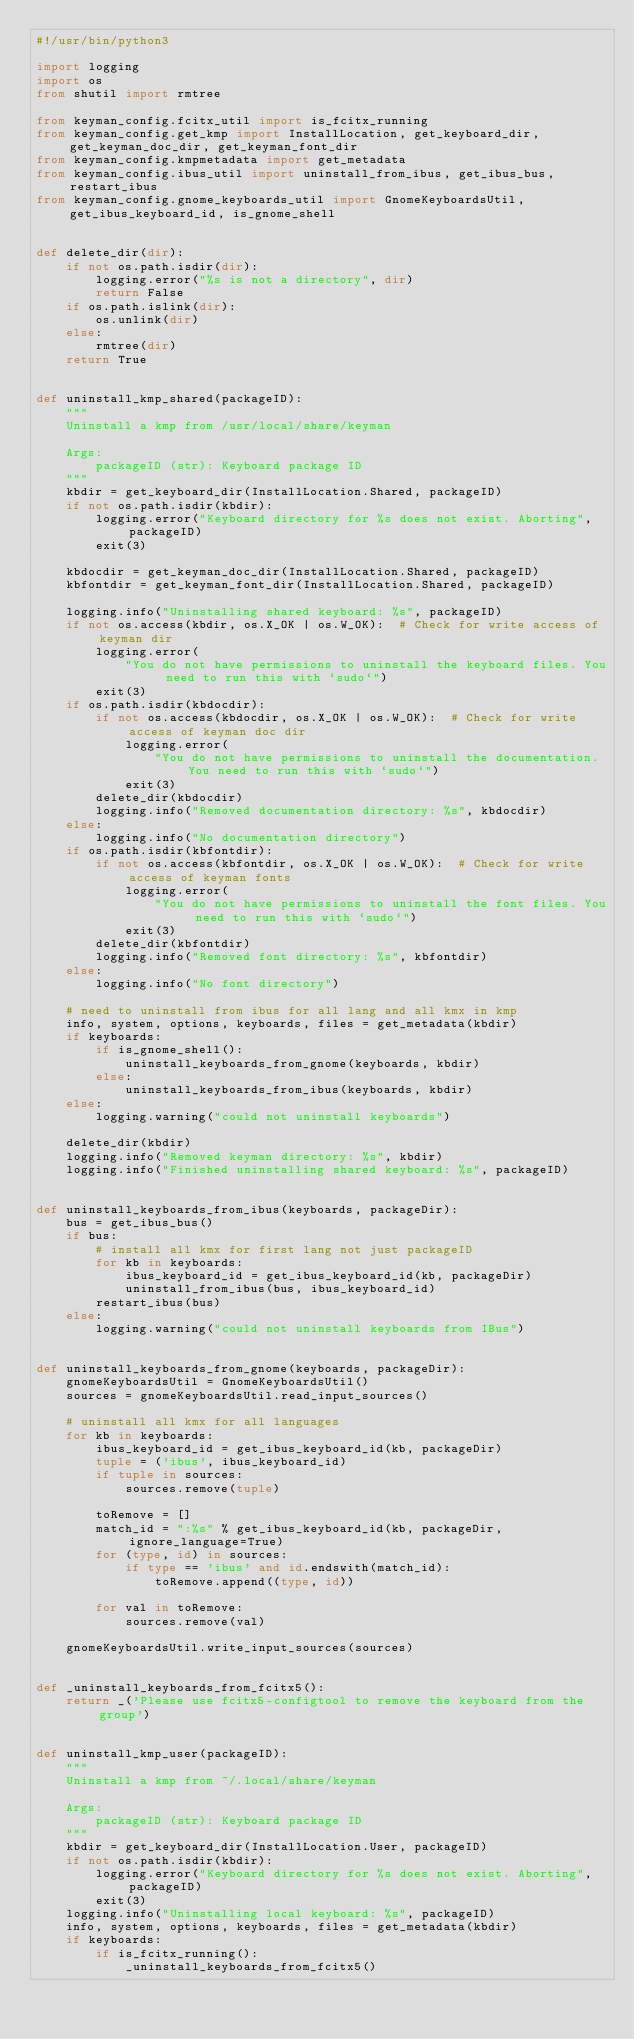<code> <loc_0><loc_0><loc_500><loc_500><_Python_>#!/usr/bin/python3

import logging
import os
from shutil import rmtree

from keyman_config.fcitx_util import is_fcitx_running
from keyman_config.get_kmp import InstallLocation, get_keyboard_dir, get_keyman_doc_dir, get_keyman_font_dir
from keyman_config.kmpmetadata import get_metadata
from keyman_config.ibus_util import uninstall_from_ibus, get_ibus_bus, restart_ibus
from keyman_config.gnome_keyboards_util import GnomeKeyboardsUtil, get_ibus_keyboard_id, is_gnome_shell


def delete_dir(dir):
    if not os.path.isdir(dir):
        logging.error("%s is not a directory", dir)
        return False
    if os.path.islink(dir):
        os.unlink(dir)
    else:
        rmtree(dir)
    return True


def uninstall_kmp_shared(packageID):
    """
    Uninstall a kmp from /usr/local/share/keyman

    Args:
        packageID (str): Keyboard package ID
    """
    kbdir = get_keyboard_dir(InstallLocation.Shared, packageID)
    if not os.path.isdir(kbdir):
        logging.error("Keyboard directory for %s does not exist. Aborting", packageID)
        exit(3)

    kbdocdir = get_keyman_doc_dir(InstallLocation.Shared, packageID)
    kbfontdir = get_keyman_font_dir(InstallLocation.Shared, packageID)

    logging.info("Uninstalling shared keyboard: %s", packageID)
    if not os.access(kbdir, os.X_OK | os.W_OK):  # Check for write access of keyman dir
        logging.error(
            "You do not have permissions to uninstall the keyboard files. You need to run this with `sudo`")
        exit(3)
    if os.path.isdir(kbdocdir):
        if not os.access(kbdocdir, os.X_OK | os.W_OK):  # Check for write access of keyman doc dir
            logging.error(
                "You do not have permissions to uninstall the documentation. You need to run this with `sudo`")
            exit(3)
        delete_dir(kbdocdir)
        logging.info("Removed documentation directory: %s", kbdocdir)
    else:
        logging.info("No documentation directory")
    if os.path.isdir(kbfontdir):
        if not os.access(kbfontdir, os.X_OK | os.W_OK):  # Check for write access of keyman fonts
            logging.error(
                "You do not have permissions to uninstall the font files. You need to run this with `sudo`")
            exit(3)
        delete_dir(kbfontdir)
        logging.info("Removed font directory: %s", kbfontdir)
    else:
        logging.info("No font directory")

    # need to uninstall from ibus for all lang and all kmx in kmp
    info, system, options, keyboards, files = get_metadata(kbdir)
    if keyboards:
        if is_gnome_shell():
            uninstall_keyboards_from_gnome(keyboards, kbdir)
        else:
            uninstall_keyboards_from_ibus(keyboards, kbdir)
    else:
        logging.warning("could not uninstall keyboards")

    delete_dir(kbdir)
    logging.info("Removed keyman directory: %s", kbdir)
    logging.info("Finished uninstalling shared keyboard: %s", packageID)


def uninstall_keyboards_from_ibus(keyboards, packageDir):
    bus = get_ibus_bus()
    if bus:
        # install all kmx for first lang not just packageID
        for kb in keyboards:
            ibus_keyboard_id = get_ibus_keyboard_id(kb, packageDir)
            uninstall_from_ibus(bus, ibus_keyboard_id)
        restart_ibus(bus)
    else:
        logging.warning("could not uninstall keyboards from IBus")


def uninstall_keyboards_from_gnome(keyboards, packageDir):
    gnomeKeyboardsUtil = GnomeKeyboardsUtil()
    sources = gnomeKeyboardsUtil.read_input_sources()

    # uninstall all kmx for all languages
    for kb in keyboards:
        ibus_keyboard_id = get_ibus_keyboard_id(kb, packageDir)
        tuple = ('ibus', ibus_keyboard_id)
        if tuple in sources:
            sources.remove(tuple)

        toRemove = []
        match_id = ":%s" % get_ibus_keyboard_id(kb, packageDir, ignore_language=True)
        for (type, id) in sources:
            if type == 'ibus' and id.endswith(match_id):
                toRemove.append((type, id))

        for val in toRemove:
            sources.remove(val)

    gnomeKeyboardsUtil.write_input_sources(sources)


def _uninstall_keyboards_from_fcitx5():
    return _('Please use fcitx5-configtool to remove the keyboard from the group')


def uninstall_kmp_user(packageID):
    """
    Uninstall a kmp from ~/.local/share/keyman

    Args:
        packageID (str): Keyboard package ID
    """
    kbdir = get_keyboard_dir(InstallLocation.User, packageID)
    if not os.path.isdir(kbdir):
        logging.error("Keyboard directory for %s does not exist. Aborting", packageID)
        exit(3)
    logging.info("Uninstalling local keyboard: %s", packageID)
    info, system, options, keyboards, files = get_metadata(kbdir)
    if keyboards:
        if is_fcitx_running():
            _uninstall_keyboards_from_fcitx5()</code> 